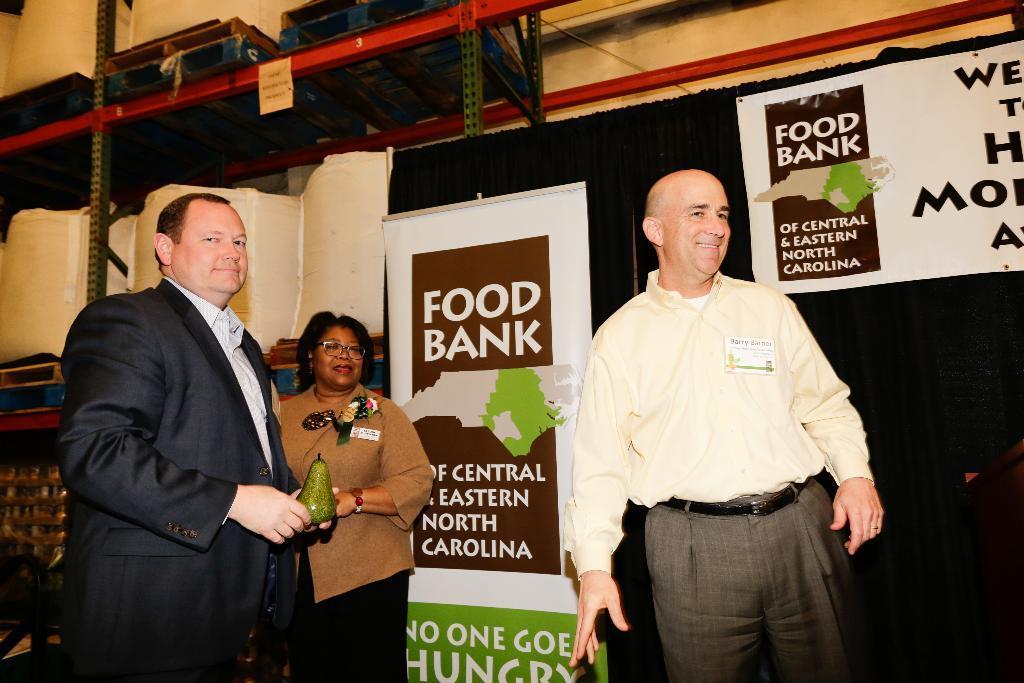Can you describe this image briefly? In the picture we can see two men are standing, and they are smiling, one man is in shirt and trouser and one man is in blazer and shirt and beside him we can see a woman standing near the wall and in the wall we can see a banner with an advertisement of a food bank and top of it we can see a rack with some boxes on it. 